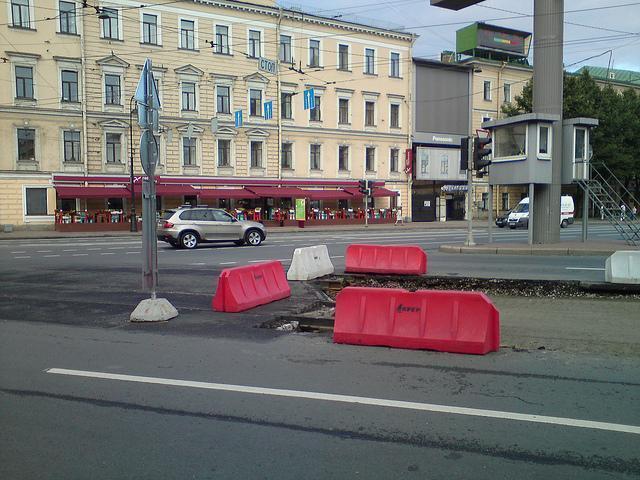How many barricades are shown?
Give a very brief answer. 5. 